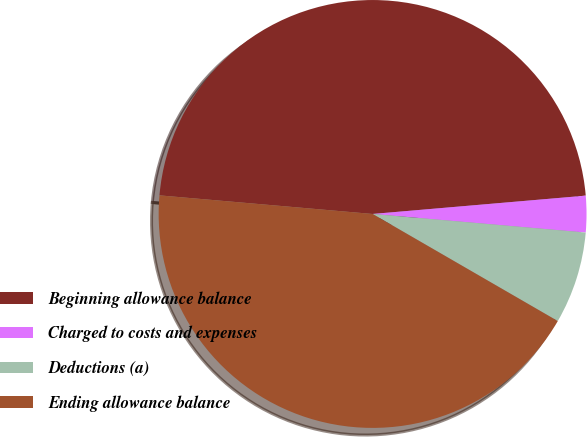<chart> <loc_0><loc_0><loc_500><loc_500><pie_chart><fcel>Beginning allowance balance<fcel>Charged to costs and expenses<fcel>Deductions (a)<fcel>Ending allowance balance<nl><fcel>47.25%<fcel>2.75%<fcel>6.96%<fcel>43.04%<nl></chart> 